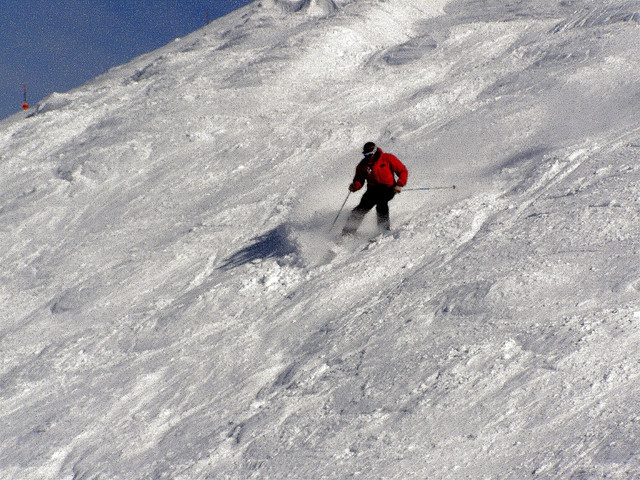Describe the objects in this image and their specific colors. I can see people in teal, black, gray, and maroon tones and skis in teal, darkgray, lightgray, and gray tones in this image. 